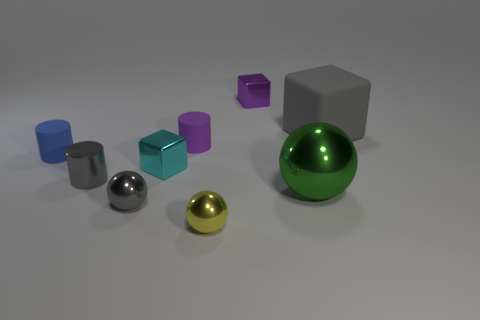There is a shiny cube that is behind the matte block; how many metallic blocks are in front of it?
Keep it short and to the point. 1. How big is the object that is both on the left side of the small yellow metallic thing and in front of the green thing?
Offer a terse response. Small. What number of matte objects are either cylinders or green things?
Keep it short and to the point. 2. What is the material of the small gray ball?
Your answer should be compact. Metal. There is a purple object in front of the gray object on the right side of the block behind the matte cube; what is it made of?
Your answer should be very brief. Rubber. What is the shape of the gray object that is the same size as the gray metal ball?
Your response must be concise. Cylinder. How many things are green spheres or metal spheres that are left of the small purple block?
Offer a very short reply. 3. Is the gray object that is on the right side of the purple cylinder made of the same material as the small cube that is behind the large matte thing?
Make the answer very short. No. What is the shape of the matte thing that is the same color as the tiny shiny cylinder?
Your answer should be compact. Cube. How many brown objects are either small matte things or big spheres?
Provide a short and direct response. 0. 